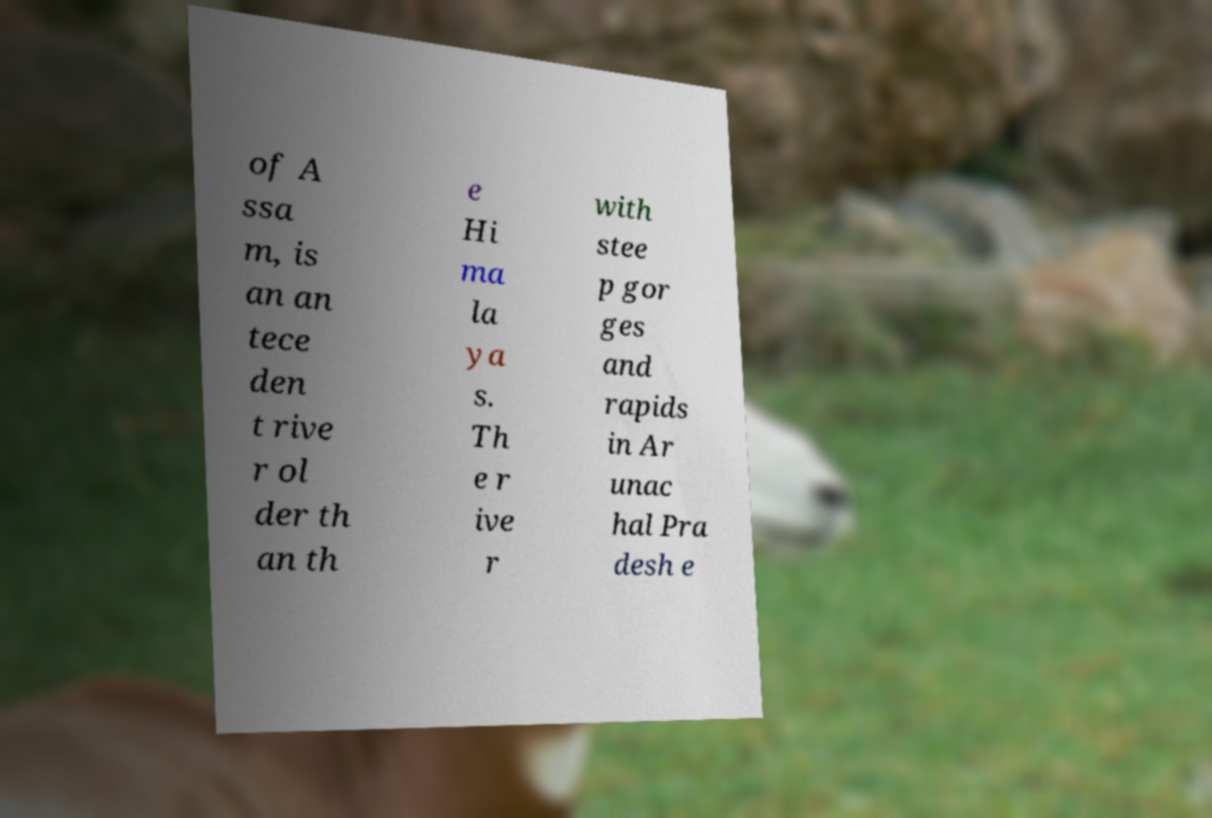For documentation purposes, I need the text within this image transcribed. Could you provide that? of A ssa m, is an an tece den t rive r ol der th an th e Hi ma la ya s. Th e r ive r with stee p gor ges and rapids in Ar unac hal Pra desh e 